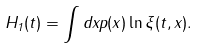Convert formula to latex. <formula><loc_0><loc_0><loc_500><loc_500>H _ { 1 } ( t ) = \int d x p ( x ) \ln \xi ( t , x ) .</formula> 